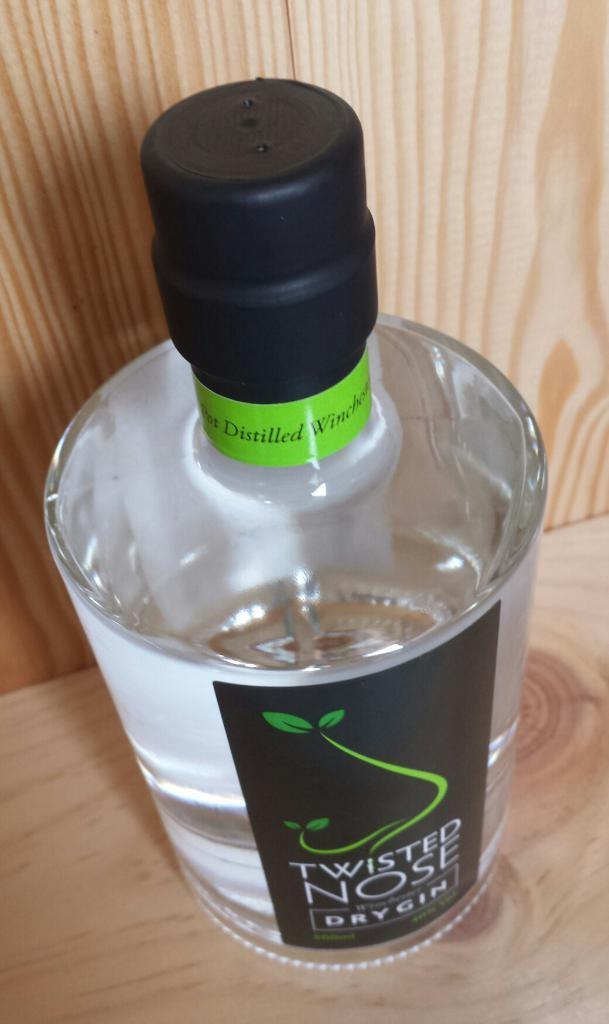<image>
Relay a brief, clear account of the picture shown. A bottle of Twisted Nose dry gin on a wooden shelf. 